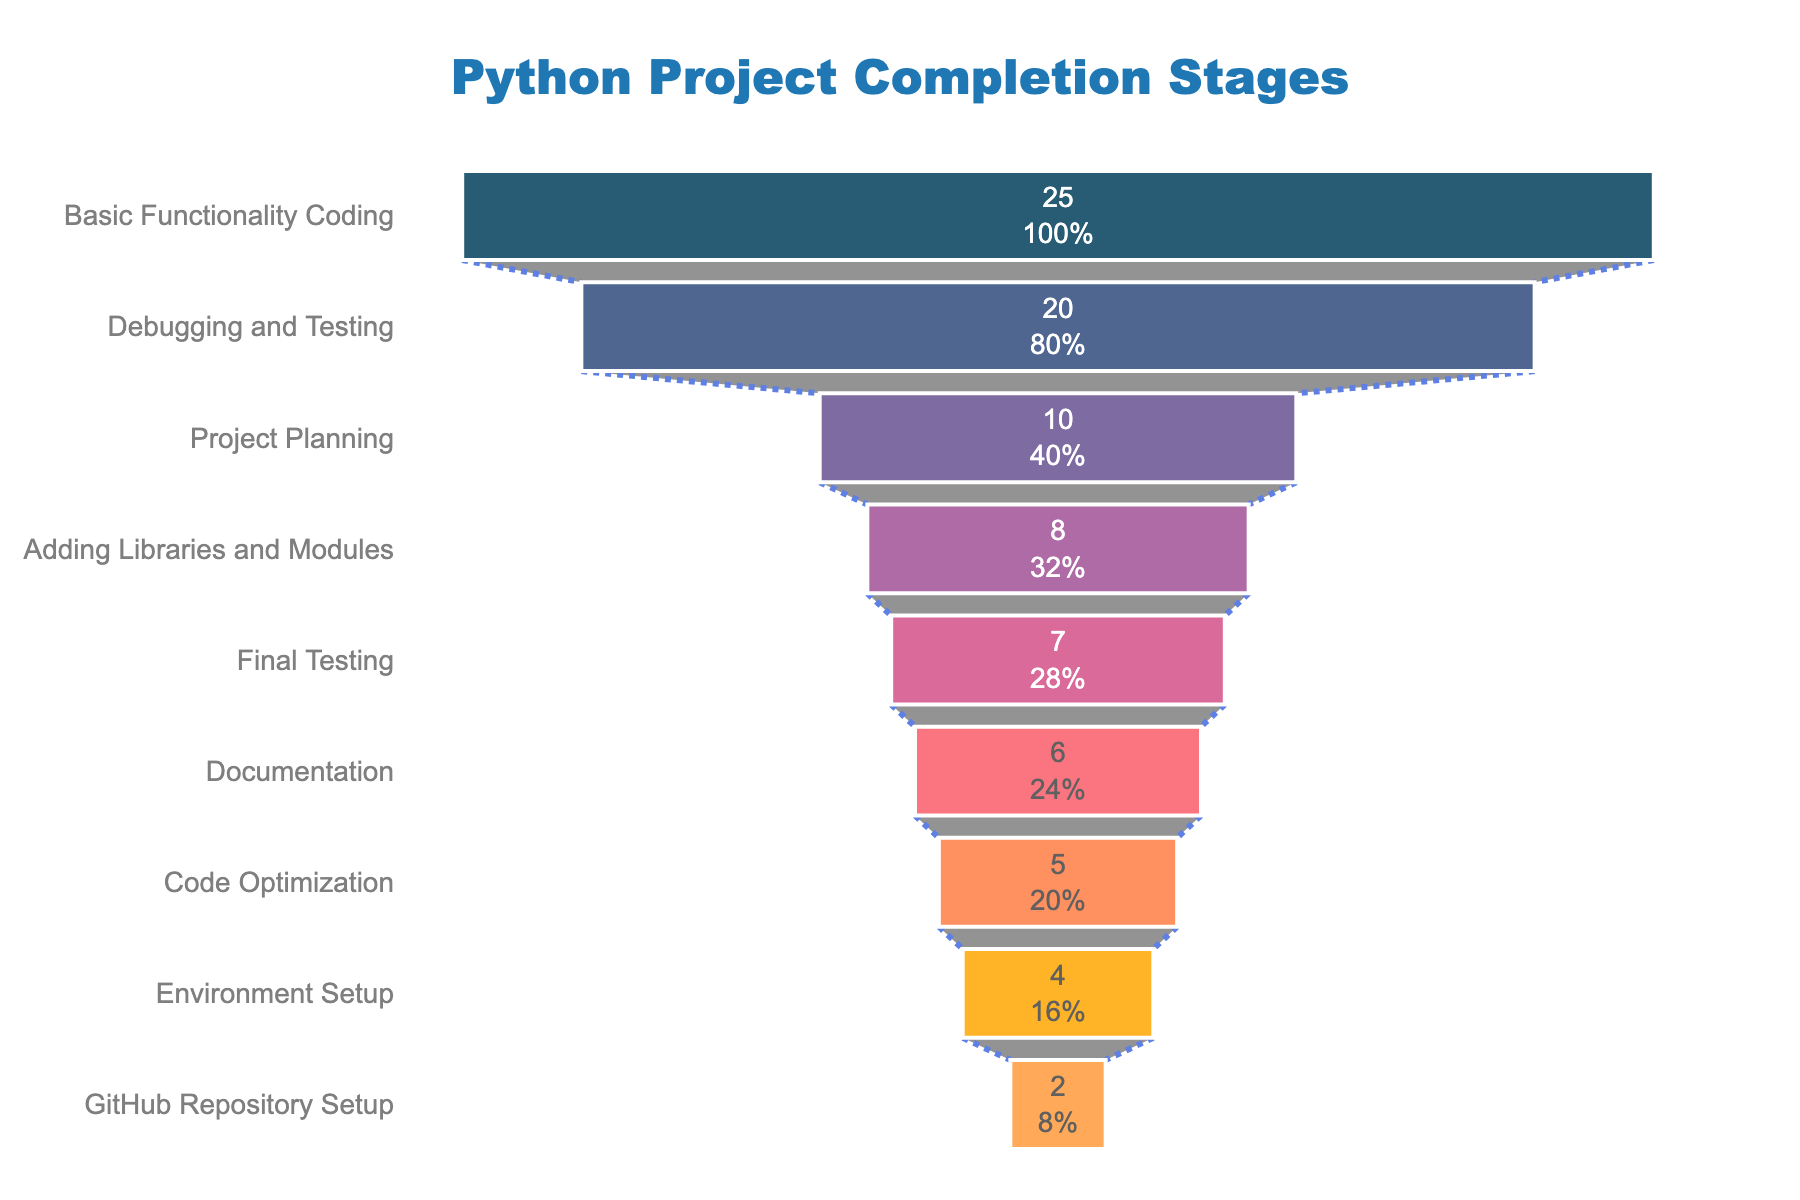What is the total amount of time spent on 'Basic Functionality Coding'? The funnel chart shows the time spent on each stage. For 'Basic Functionality Coding', the time is indicated inside the corresponding section of the funnel as 25 hours.
Answer: 25 hours Which stage has the least time allocated? To answer this, look for the smallest section in the funnel chart. 'GitHub Repository Setup' has the smallest width with 2 hours.
Answer: GitHub Repository Setup How many stages are there in total? Count the number of distinct sections in the funnel chart. There are nine stages visible in the funnel.
Answer: 9 stages What is the difference in time spent between 'Project Planning' and 'Environment Setup'? Refer to the funnel chart, where 'Project Planning' is 10 hours and 'Environment Setup' is 4 hours. The difference is 10 - 4 = 6 hours.
Answer: 6 hours Which stage follows 'Debugging and Testing' in the funnel chart? According to the funnel chart sequence, 'Debugging and Testing' is followed by 'Documentation'.
Answer: Documentation What percentage of the initial time is spent on 'Debugging and Testing'? The funnel chart displays text information inside each section. The percentage for 'Debugging and Testing' is given in addition to the time spent in that stage. According to the chart, it’s X % (a specific value shown in the chart).
Answer: [Percentage value as shown in the chart] Is more time spent on 'Code Optimization' or 'Final Testing'? Compare the time representations in the funnel chart. 'Final Testing' has 7 hours, while 'Code Optimization' has 5 hours. Hence, more time is spent on 'Final Testing'.
Answer: Final Testing What is the overall time taken from 'Basic Functionality Coding' to 'Final Testing'? Sum the hours for: Basic Functionality Coding (25), Adding Libraries and Modules (8), Debugging and Testing (20), Documentation (6), Code Optimization (5), Final Testing (7). Total is 25 + 8 + 20 + 6 + 5 + 7 = 71 hours.
Answer: 71 hours How does the time spent on 'Adding Libraries and Modules' compare to 'Code Optimization'? 'Adding Libraries and Modules' takes 8 hours while 'Code Optimization' takes 5 hours based on the funnel chart. 8 hours is greater than 5 hours.
Answer: Adding Libraries and Modules What are the stages where more than 10 hours are spent? Identify stages with times greater than 10 hours in the funnel chart. 'Basic Functionality Coding' (25 hours) and 'Debugging and Testing' (20 hours) meet this criteria.
Answer: Basic Functionality Coding, Debugging and Testing 